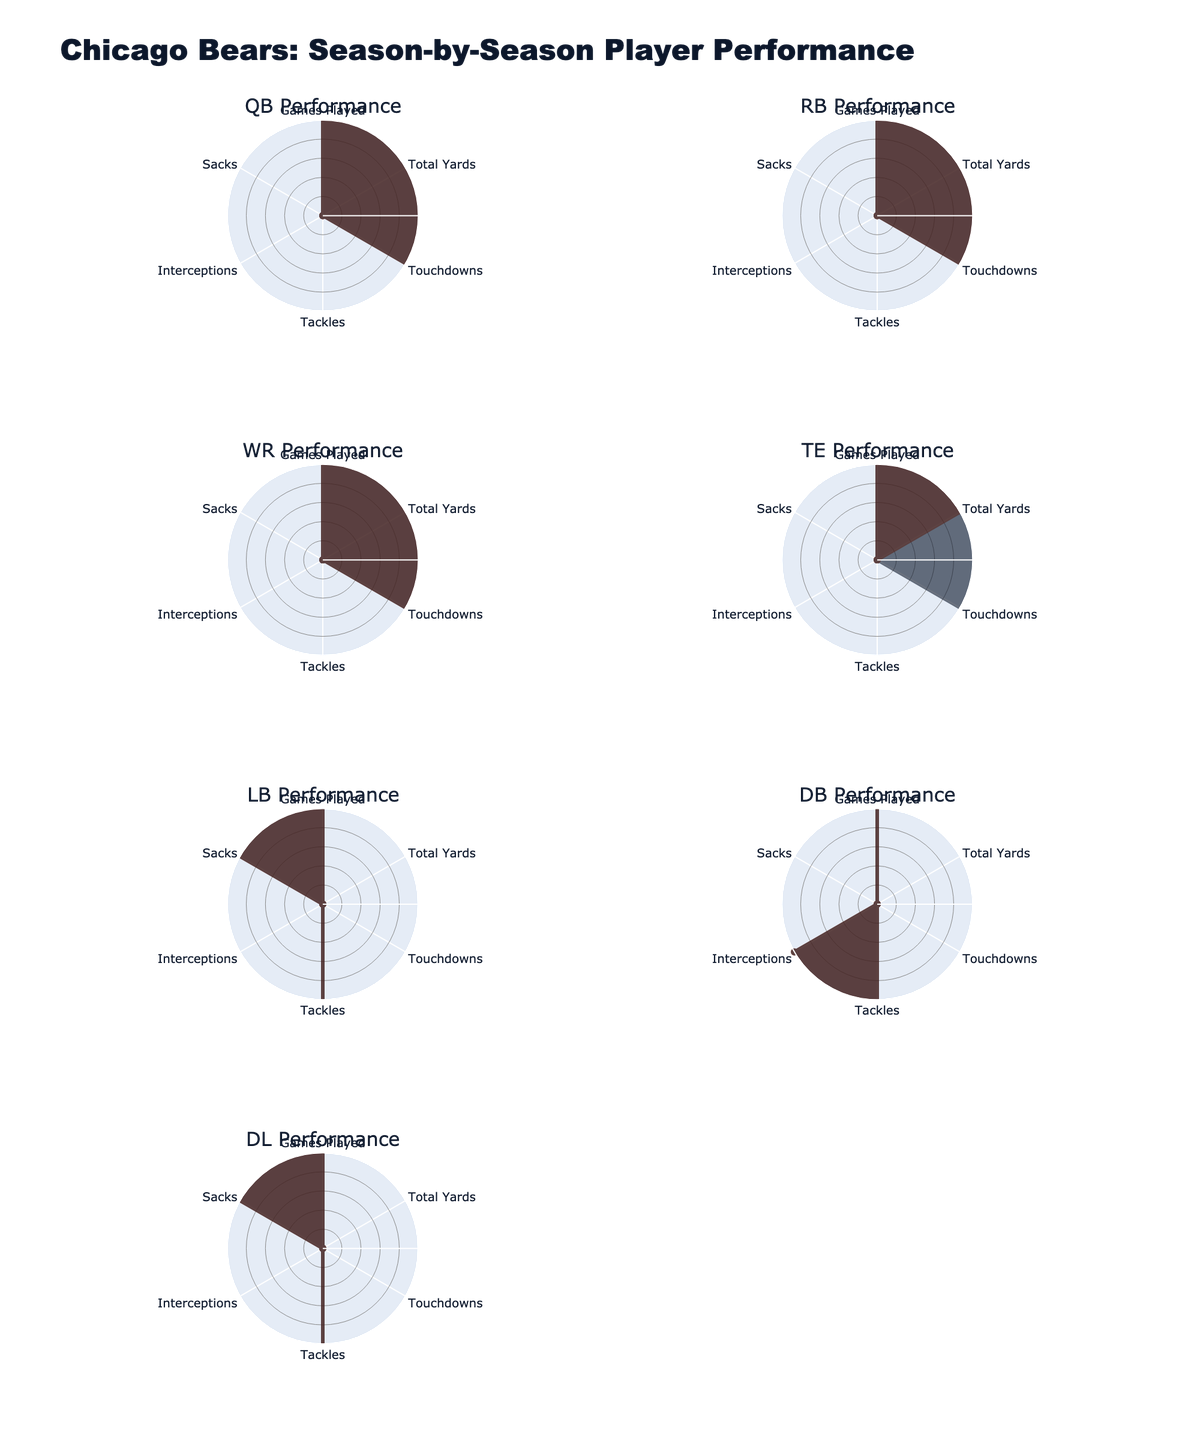How many positions are displayed in the radar charts? The radar charts visualize player performance across multiple positions. Counting the subplot titles, we can identify the number of unique positions.
Answer: 6 Which player had the most total yards as a running back in the 2022 season? We look at the radar chart for the running back position for the 2022 season and identify the player with the largest value in the "Total Yards" category in that sector of the graph.
Answer: David Montgomery How did Justin Fields' touchdowns change from 2021 to 2022? To answer this, we examine the radar charts for the quarterback position, comparing the values under the "Touchdowns" category for 2021 and 2022.
Answer: Increased What is the range of values for sacks achieved by linebackers? We analyze the radar charts for the linebacker position, focusing on the "Sacks" category to identify the minimum and maximum values. Roquan Smith had sacks of 3.0 and 3.5 in 2021 and 2022, respectively.
Answer: 3.0 to 3.5 Among the wide receivers, who showed a decrease in total yards from 2021 to 2022? In the radar charts for the wide receiver position, we observe the "Total Yards" category for both years. The player with a declining trend is noted.
Answer: Darnell Mooney Compare the total touchdowns scored by the tight end position players in 2021 and 2022. We look at the radar charts for the tight end position, specifically the "Touchdowns" category, and compare the numbers between the two seasons.
Answer: 0 in 2021, 7 in 2022 Which defensive lineman had a significant drop in sacks from 2021 to 2022? Referring to the radar charts for the defensive line position, we analyze the "Sacks" category for both seasons and identify the player with a noticeable decrease.
Answer: Robert Quinn How many games did Jaylon Johnson play in the 2022 season, and how does it compare to 2021? Checking the radar charts for the defensive back position, we find the "Games Played" values for the respective seasons and compare them.
Answer: 16 in 2022, 15 in 2021 Calculate the average number of tackles made by Roquan Smith across 2021 and 2022 seasons. First, obtain the total tackles from the radar charts for both years. Add the values (163 and 160) and divide by 2 to get the average.
Answer: 161.5 Which player had the highest value in sacks among all positions across both seasons? We examine the "Sacks" category for all positions and seasons, comparing the values to identify the maximum.
Answer: Robert Quinn in 2021 